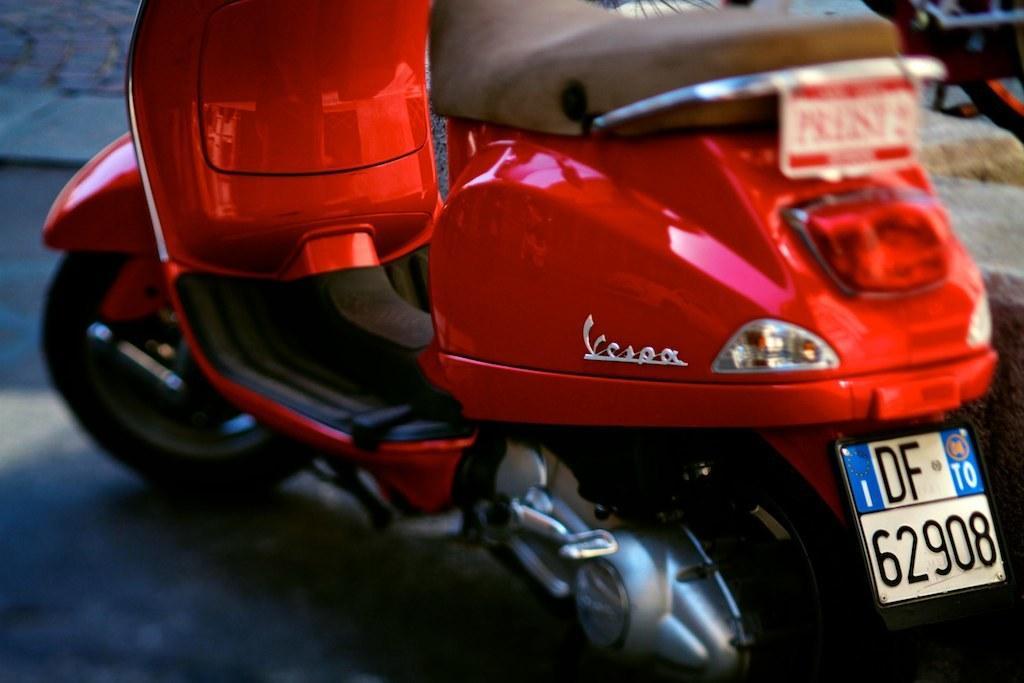In one or two sentences, can you explain what this image depicts? In this image, we can see a motorbike with a number plate on the path. In the top left corner, there is a walkway. In the top right of the image, we can see a few objects. 